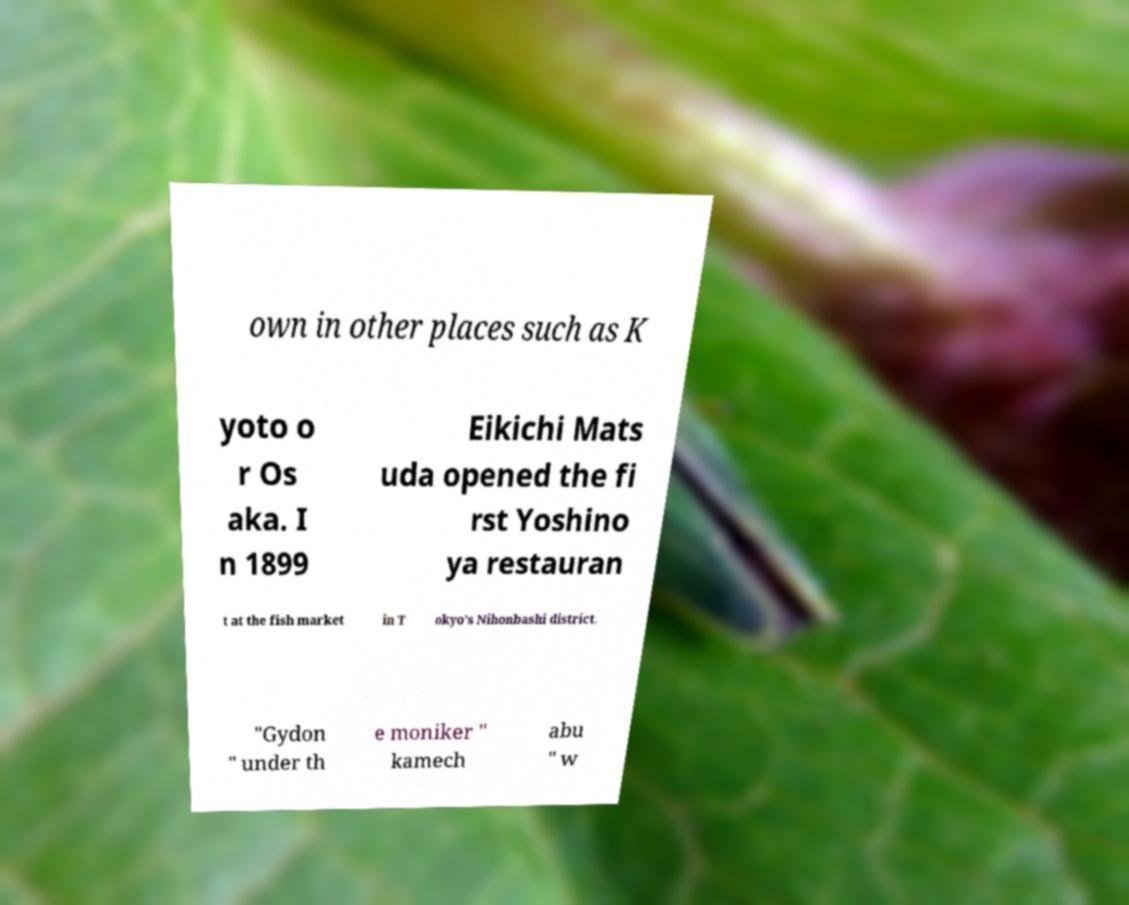What messages or text are displayed in this image? I need them in a readable, typed format. own in other places such as K yoto o r Os aka. I n 1899 Eikichi Mats uda opened the fi rst Yoshino ya restauran t at the fish market in T okyo's Nihonbashi district. "Gydon " under th e moniker " kamech abu " w 